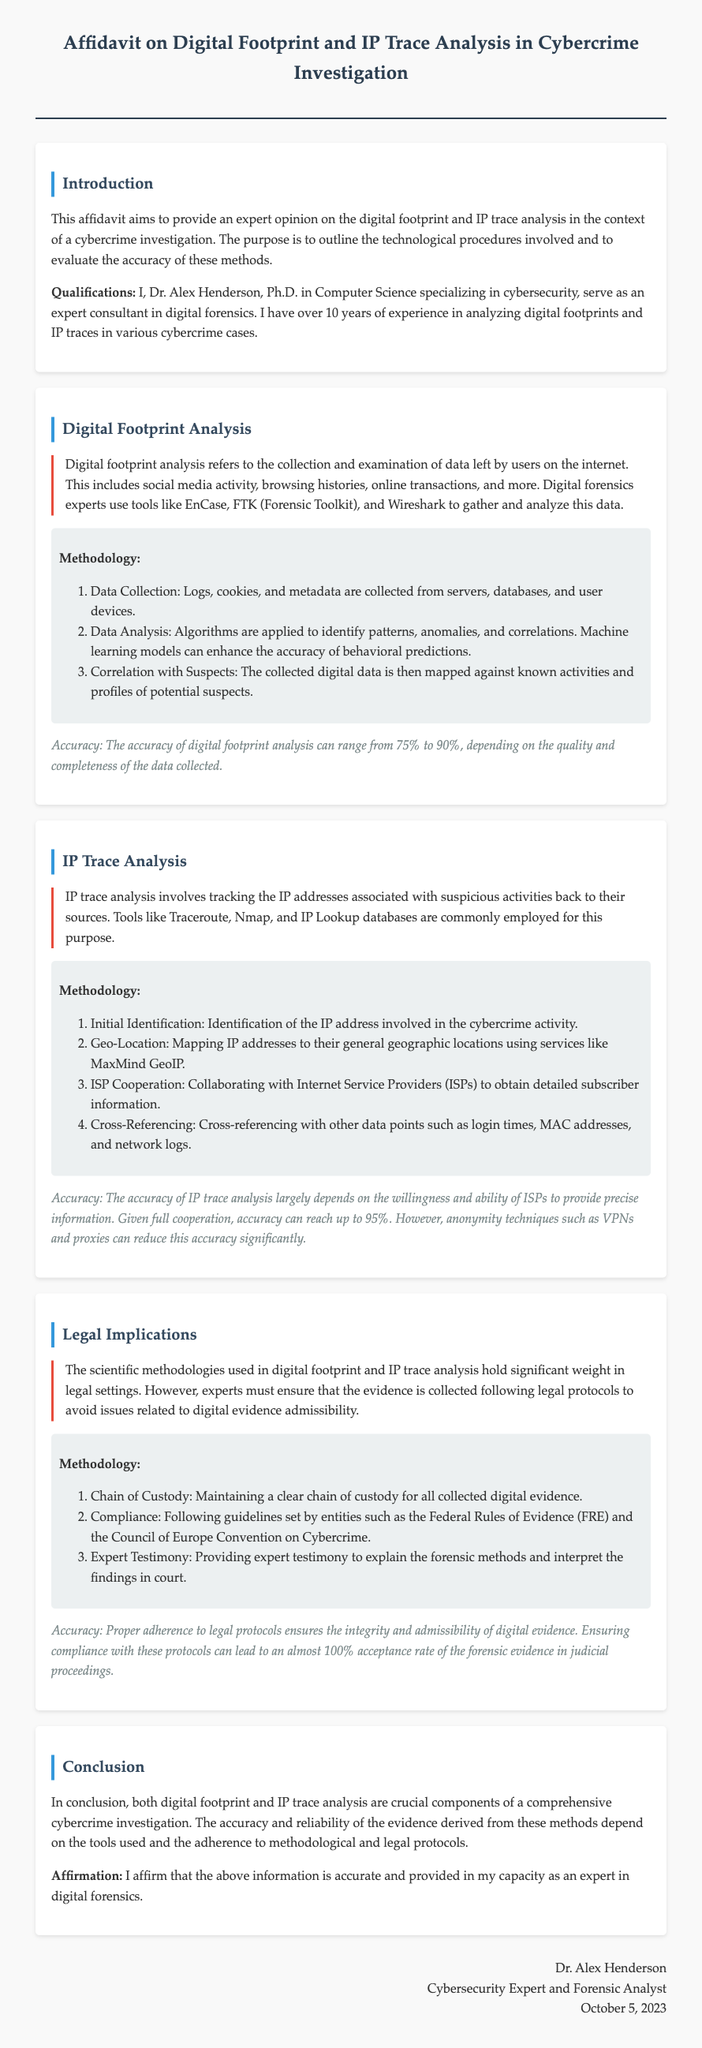What is the name of the expert consulting in digital forensics? The document states that Dr. Alex Henderson serves as an expert consultant.
Answer: Dr. Alex Henderson What is the primary focus of the affidavit? The affidavit provides an expert opinion on digital footprint and IP trace analysis in cybercrime investigations.
Answer: Digital footprint and IP trace analysis Which tools are mentioned for digital footprint analysis? Tools like EnCase, FTK, and Wireshark are specifically mentioned for this analysis.
Answer: EnCase, FTK, Wireshark What is the accuracy range for digital footprint analysis? The document provides a range of 75% to 90% for the accuracy of digital footprint analysis.
Answer: 75% to 90% What is the maximum accuracy for IP trace analysis with ISP cooperation? The document indicates that with full cooperation, the accuracy can reach up to 95%.
Answer: 95% What is a key legal protocol mentioned for maintaining digital evidence integrity? The chain of custody is highlighted as an essential legal protocol for digital evidence.
Answer: Chain of Custody What date was this affidavit signed? The document mentions that the affidavit was signed on October 5, 2023.
Answer: October 5, 2023 What is emphasized as necessary for the admissibility of digital evidence in court? The document stresses the need for adherence to legal protocols to ensure the admissibility of digital evidence.
Answer: Adherence to legal protocols 